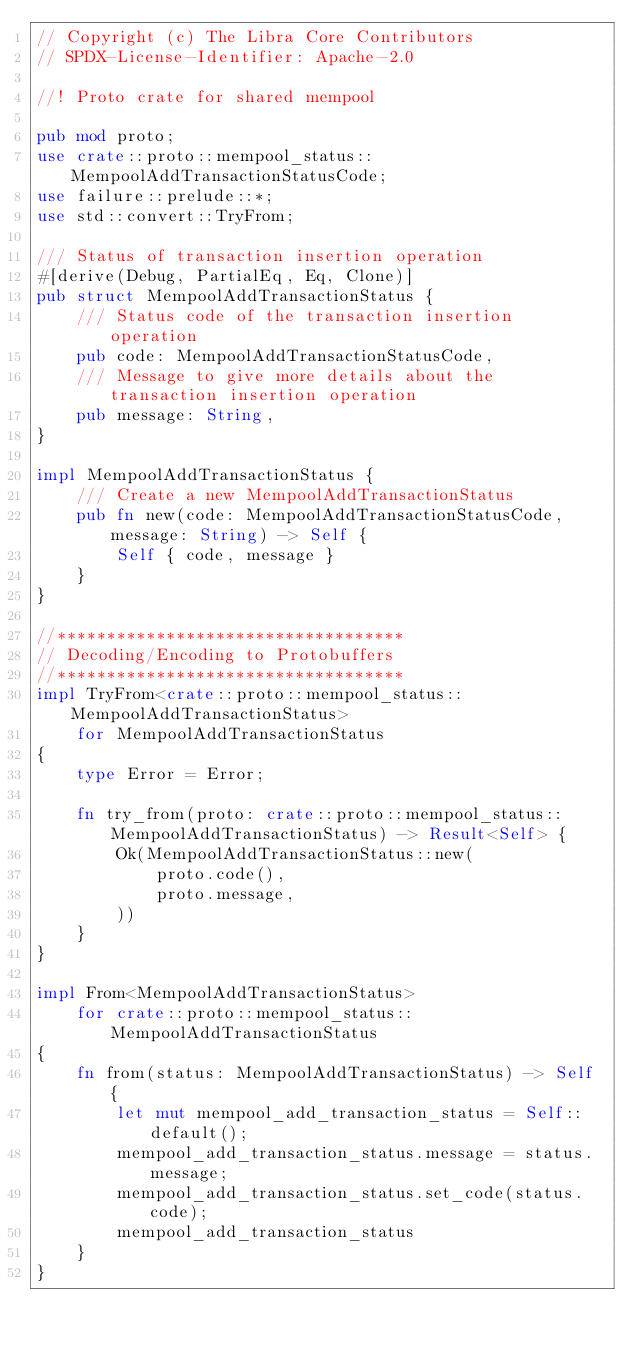<code> <loc_0><loc_0><loc_500><loc_500><_Rust_>// Copyright (c) The Libra Core Contributors
// SPDX-License-Identifier: Apache-2.0

//! Proto crate for shared mempool

pub mod proto;
use crate::proto::mempool_status::MempoolAddTransactionStatusCode;
use failure::prelude::*;
use std::convert::TryFrom;

/// Status of transaction insertion operation
#[derive(Debug, PartialEq, Eq, Clone)]
pub struct MempoolAddTransactionStatus {
    /// Status code of the transaction insertion operation
    pub code: MempoolAddTransactionStatusCode,
    /// Message to give more details about the transaction insertion operation
    pub message: String,
}

impl MempoolAddTransactionStatus {
    /// Create a new MempoolAddTransactionStatus
    pub fn new(code: MempoolAddTransactionStatusCode, message: String) -> Self {
        Self { code, message }
    }
}

//***********************************
// Decoding/Encoding to Protobuffers
//***********************************
impl TryFrom<crate::proto::mempool_status::MempoolAddTransactionStatus>
    for MempoolAddTransactionStatus
{
    type Error = Error;

    fn try_from(proto: crate::proto::mempool_status::MempoolAddTransactionStatus) -> Result<Self> {
        Ok(MempoolAddTransactionStatus::new(
            proto.code(),
            proto.message,
        ))
    }
}

impl From<MempoolAddTransactionStatus>
    for crate::proto::mempool_status::MempoolAddTransactionStatus
{
    fn from(status: MempoolAddTransactionStatus) -> Self {
        let mut mempool_add_transaction_status = Self::default();
        mempool_add_transaction_status.message = status.message;
        mempool_add_transaction_status.set_code(status.code);
        mempool_add_transaction_status
    }
}
</code> 